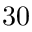Convert formula to latex. <formula><loc_0><loc_0><loc_500><loc_500>3 0</formula> 